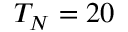Convert formula to latex. <formula><loc_0><loc_0><loc_500><loc_500>T _ { N } = 2 0</formula> 